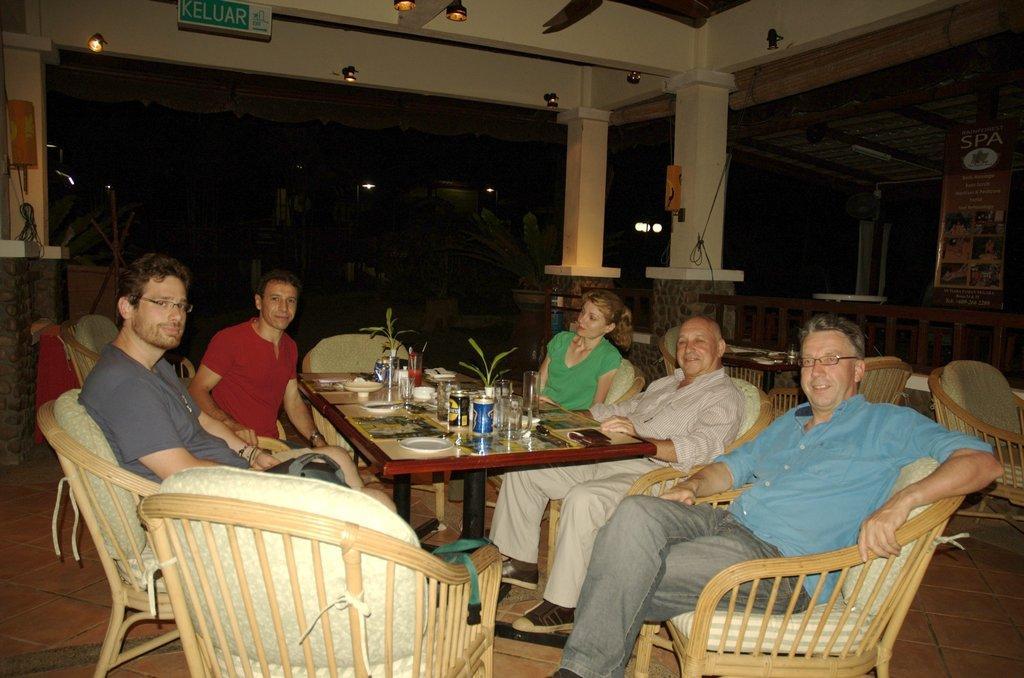Describe this image in one or two sentences. There are four men and a woman sitting on the chair at the table. On the table there are glasses,plates,flower vase and bottles. In the background we can see hoarding,tables,chairs and lights. 